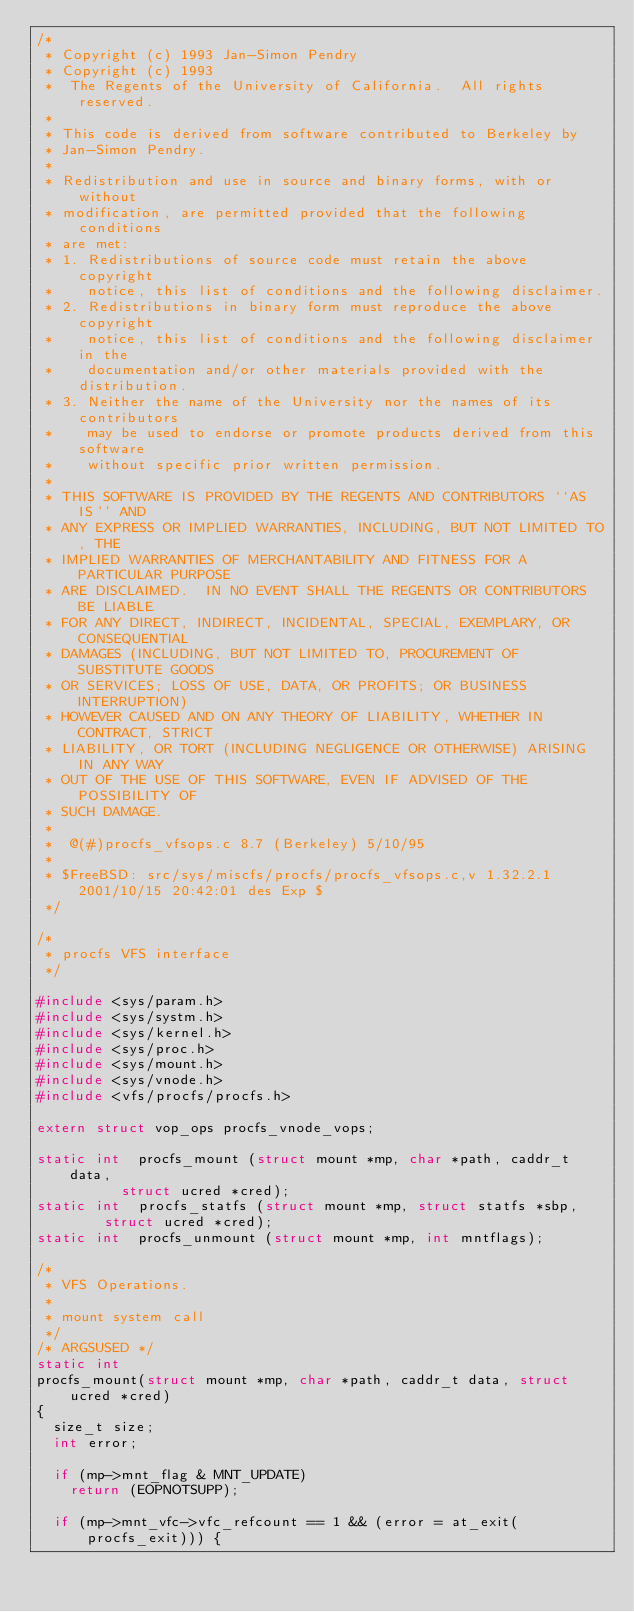<code> <loc_0><loc_0><loc_500><loc_500><_C_>/*
 * Copyright (c) 1993 Jan-Simon Pendry
 * Copyright (c) 1993
 *	The Regents of the University of California.  All rights reserved.
 *
 * This code is derived from software contributed to Berkeley by
 * Jan-Simon Pendry.
 *
 * Redistribution and use in source and binary forms, with or without
 * modification, are permitted provided that the following conditions
 * are met:
 * 1. Redistributions of source code must retain the above copyright
 *    notice, this list of conditions and the following disclaimer.
 * 2. Redistributions in binary form must reproduce the above copyright
 *    notice, this list of conditions and the following disclaimer in the
 *    documentation and/or other materials provided with the distribution.
 * 3. Neither the name of the University nor the names of its contributors
 *    may be used to endorse or promote products derived from this software
 *    without specific prior written permission.
 *
 * THIS SOFTWARE IS PROVIDED BY THE REGENTS AND CONTRIBUTORS ``AS IS'' AND
 * ANY EXPRESS OR IMPLIED WARRANTIES, INCLUDING, BUT NOT LIMITED TO, THE
 * IMPLIED WARRANTIES OF MERCHANTABILITY AND FITNESS FOR A PARTICULAR PURPOSE
 * ARE DISCLAIMED.  IN NO EVENT SHALL THE REGENTS OR CONTRIBUTORS BE LIABLE
 * FOR ANY DIRECT, INDIRECT, INCIDENTAL, SPECIAL, EXEMPLARY, OR CONSEQUENTIAL
 * DAMAGES (INCLUDING, BUT NOT LIMITED TO, PROCUREMENT OF SUBSTITUTE GOODS
 * OR SERVICES; LOSS OF USE, DATA, OR PROFITS; OR BUSINESS INTERRUPTION)
 * HOWEVER CAUSED AND ON ANY THEORY OF LIABILITY, WHETHER IN CONTRACT, STRICT
 * LIABILITY, OR TORT (INCLUDING NEGLIGENCE OR OTHERWISE) ARISING IN ANY WAY
 * OUT OF THE USE OF THIS SOFTWARE, EVEN IF ADVISED OF THE POSSIBILITY OF
 * SUCH DAMAGE.
 *
 *	@(#)procfs_vfsops.c	8.7 (Berkeley) 5/10/95
 *
 * $FreeBSD: src/sys/miscfs/procfs/procfs_vfsops.c,v 1.32.2.1 2001/10/15 20:42:01 des Exp $
 */

/*
 * procfs VFS interface
 */

#include <sys/param.h>
#include <sys/systm.h>
#include <sys/kernel.h>
#include <sys/proc.h>
#include <sys/mount.h>
#include <sys/vnode.h>
#include <vfs/procfs/procfs.h>

extern struct vop_ops procfs_vnode_vops;

static int	procfs_mount (struct mount *mp, char *path, caddr_t data,
				  struct ucred *cred);
static int	procfs_statfs (struct mount *mp, struct statfs *sbp,
				struct ucred *cred);
static int	procfs_unmount (struct mount *mp, int mntflags);

/*
 * VFS Operations.
 *
 * mount system call
 */
/* ARGSUSED */
static int
procfs_mount(struct mount *mp, char *path, caddr_t data, struct ucred *cred)
{
	size_t size;
	int error;

	if (mp->mnt_flag & MNT_UPDATE)
		return (EOPNOTSUPP);

	if (mp->mnt_vfc->vfc_refcount == 1 && (error = at_exit(procfs_exit))) {</code> 